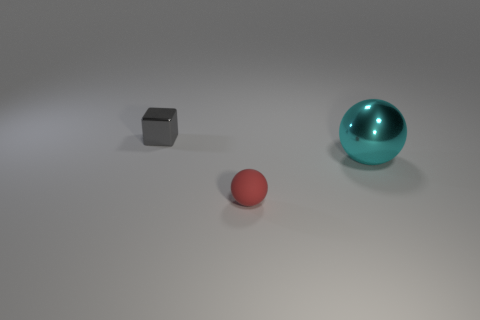Is the number of big cyan things that are right of the small shiny object greater than the number of tiny rubber objects?
Your response must be concise. No. Is there a metal ball?
Provide a short and direct response. Yes. What number of gray shiny blocks are the same size as the red sphere?
Your answer should be compact. 1. Are there more big cyan things left of the big metal ball than gray metallic things on the left side of the tiny gray metal thing?
Keep it short and to the point. No. There is a cube that is the same size as the red rubber thing; what material is it?
Provide a succinct answer. Metal. The small shiny thing has what shape?
Your answer should be compact. Cube. What number of blue things are tiny rubber things or small objects?
Your answer should be very brief. 0. There is a gray thing that is the same material as the cyan object; what size is it?
Give a very brief answer. Small. Are the tiny object on the right side of the tiny gray shiny thing and the object that is behind the big cyan metallic object made of the same material?
Give a very brief answer. No. How many spheres are small objects or gray objects?
Your answer should be compact. 1. 